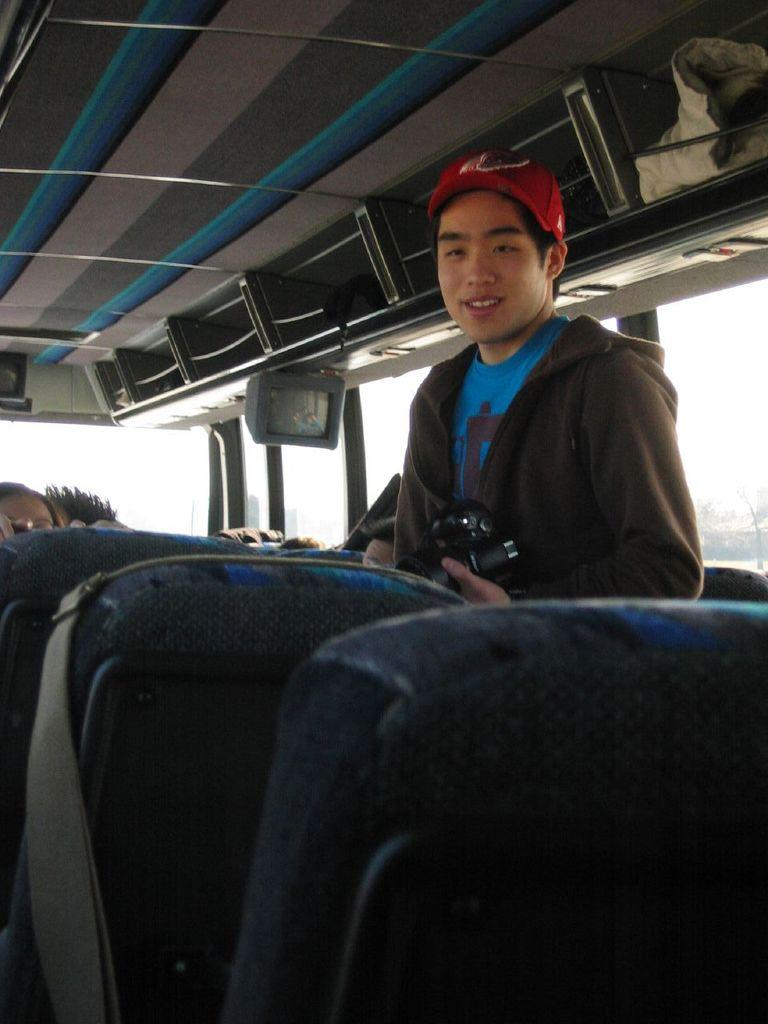What is happening in the image? There are people inside a vehicle in the image. What can be found inside the vehicle? There are seats, a television, and objects visible in the vehicle. What type of windows does the vehicle have? The vehicle has glass windows. Where is the pen located in the image? There is no pen present in the image. What type of insect can be seen crawling on the television in the image? There is no insect present in the image. 